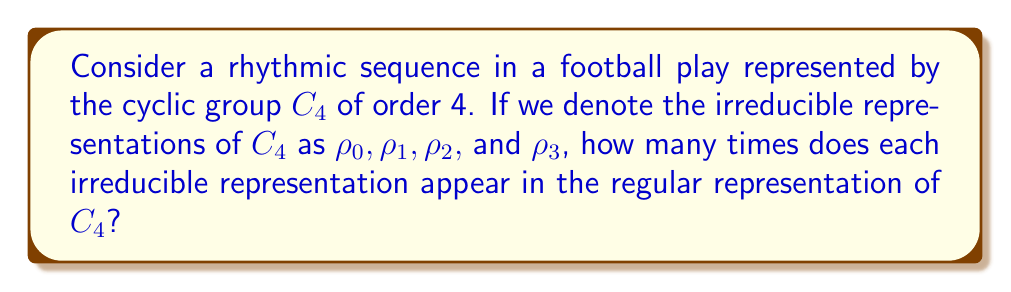Solve this math problem. Let's approach this step-by-step:

1) First, recall that for any finite group $G$, the regular representation decomposes into a direct sum of all irreducible representations, with each appearing with multiplicity equal to its dimension.

2) For the cyclic group $C_4$, we have four irreducible representations, all of dimension 1. These are:

   $\rho_0(g^k) = 1$ (the trivial representation)
   $\rho_1(g^k) = i^k$
   $\rho_2(g^k) = (-1)^k$
   $\rho_3(g^k) = (-i)^k$

   where $g$ is a generator of $C_4$ and $k = 0, 1, 2, 3$.

3) The character table for $C_4$ is:

   $$\begin{array}{c|cccc}
    & e & g & g^2 & g^3 \\
   \hline
   \rho_0 & 1 & 1 & 1 & 1 \\
   \rho_1 & 1 & i & -1 & -i \\
   \rho_2 & 1 & -1 & 1 & -1 \\
   \rho_3 & 1 & -i & -1 & i
   \end{array}$$

4) The regular representation has character $(4,0,0,0)$, as it permutes the basis elements.

5) By the decomposition of the regular representation, we know that:

   $4\rho_0 \oplus 4\rho_1 \oplus 4\rho_2 \oplus 4\rho_3 = \text{Regular Representation}$

6) This is because each irreducible representation appears with multiplicity equal to its dimension, which is 1 for all irreducible representations of $C_4$.

Therefore, each irreducible representation appears exactly 4 times in the regular representation of $C_4$.
Answer: 4 times each 